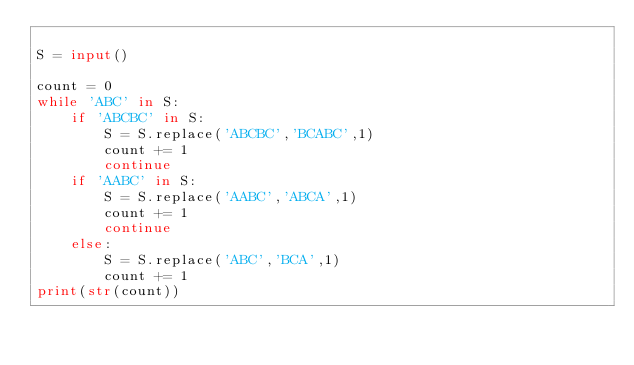<code> <loc_0><loc_0><loc_500><loc_500><_Python_>
S = input()

count = 0
while 'ABC' in S:
    if 'ABCBC' in S:
        S = S.replace('ABCBC','BCABC',1)
        count += 1
        continue
    if 'AABC' in S:
        S = S.replace('AABC','ABCA',1)
        count += 1
        continue
    else:
        S = S.replace('ABC','BCA',1)
        count += 1
print(str(count))</code> 